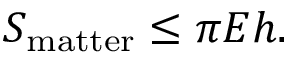<formula> <loc_0><loc_0><loc_500><loc_500>S _ { m a t t e r } \leq \pi E h .</formula> 